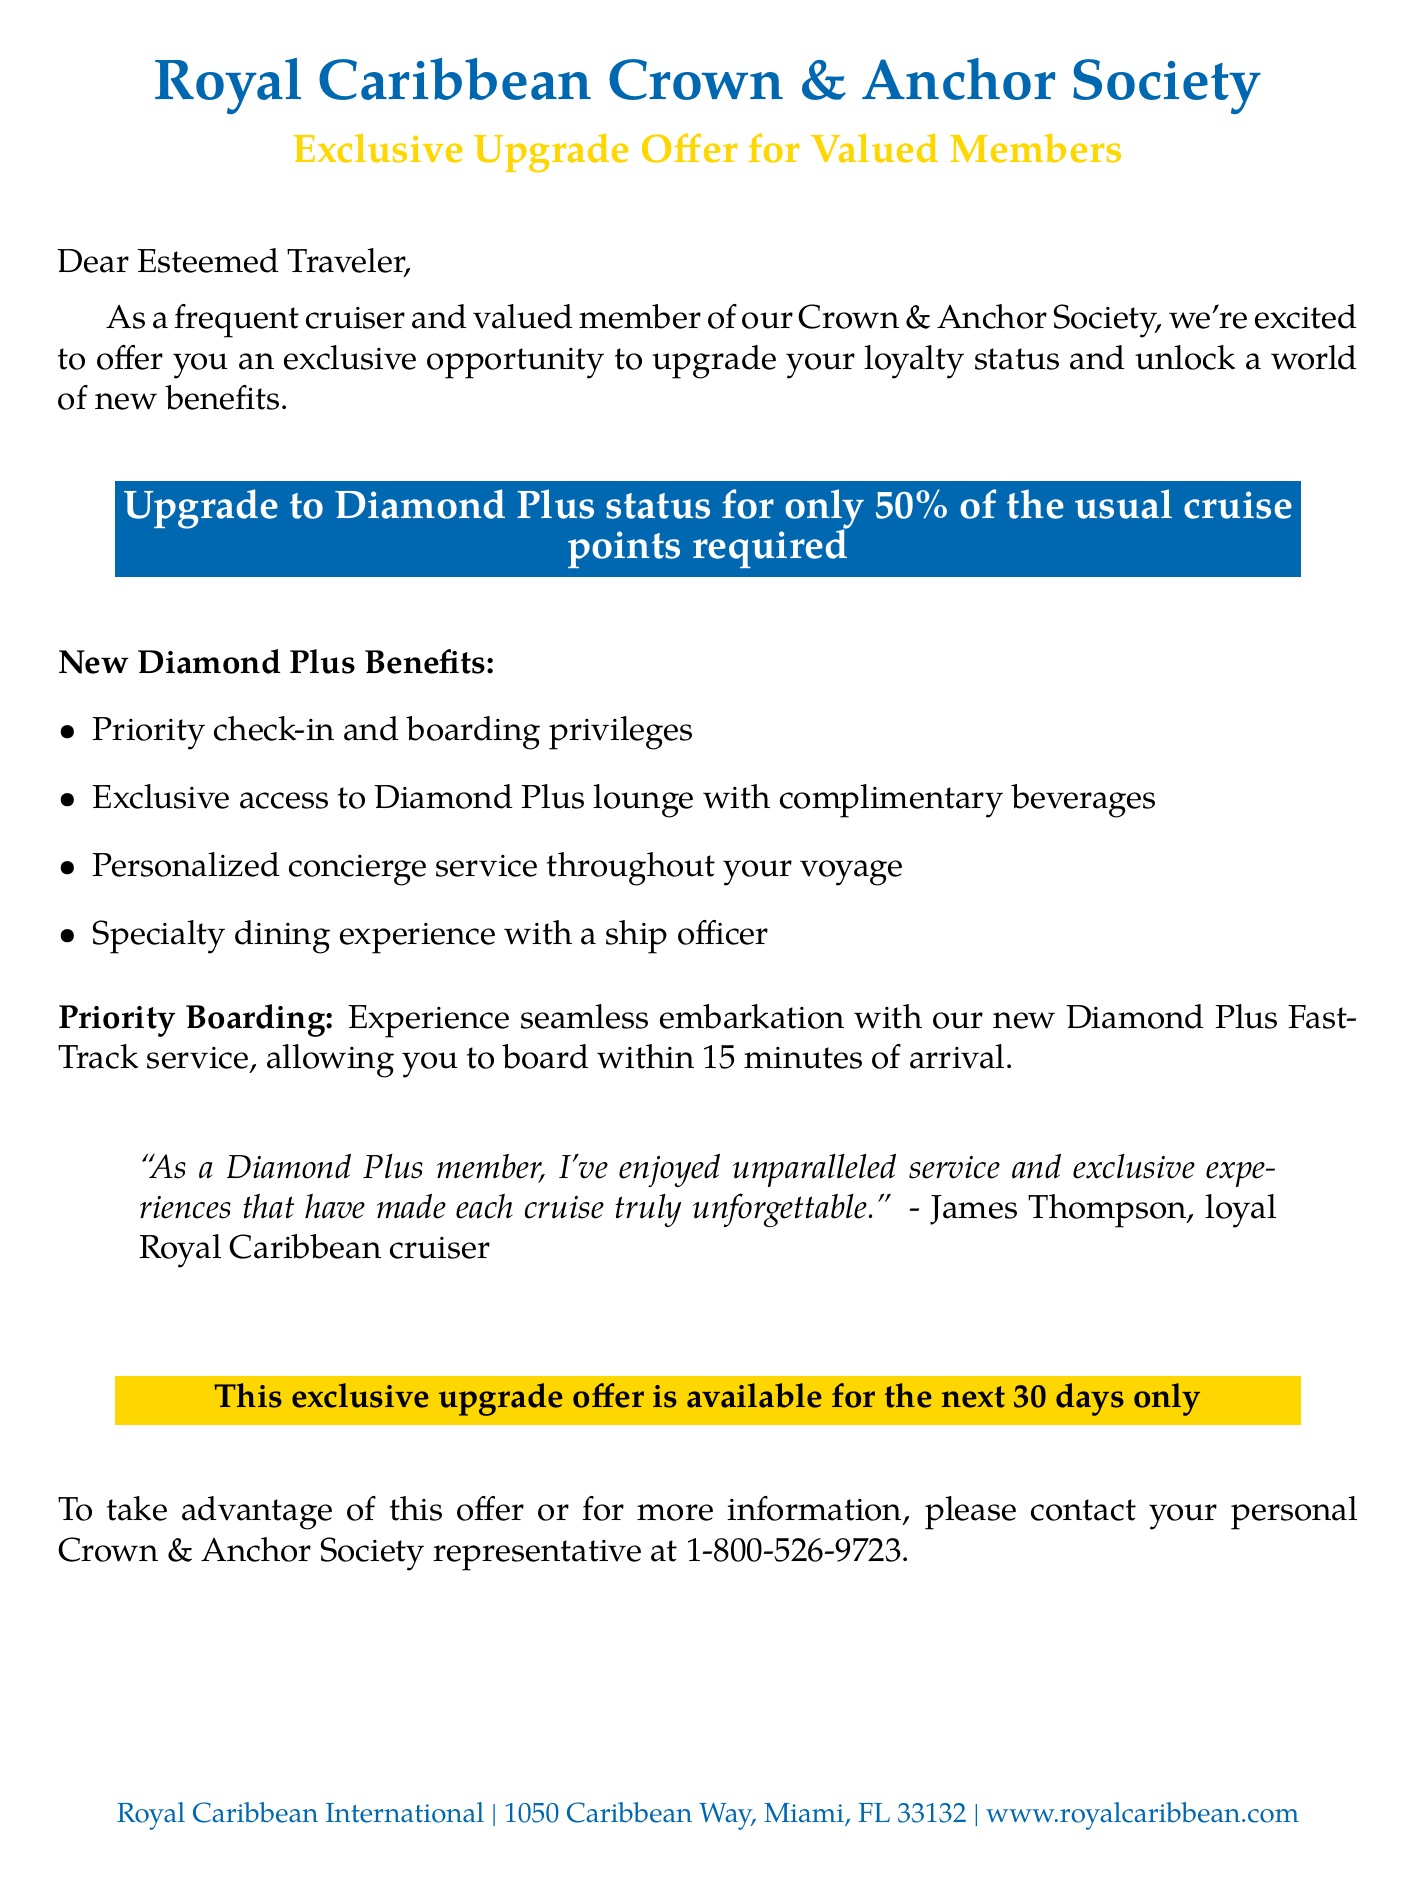What is the name of the loyalty program? The name of the loyalty program is mentioned as "Crown & Anchor Society."
Answer: Crown & Anchor Society What is the upgrade offer for? The upgrade offer is specifically for "Diamond Plus status."
Answer: Diamond Plus status How much of the usual cruise points is required for the upgrade? The document states that the upgrade requires "50% of the usual cruise points."
Answer: 50% What is one of the new benefits of Diamond Plus status? The new benefits listed include "Priority check-in and boarding privileges."
Answer: Priority check-in and boarding privileges What is the name of the FastTrack service? The FastTrack service mentioned in the document is called "Diamond Plus FastTrack."
Answer: Diamond Plus FastTrack How long is the exclusive upgrade offer available? The document states that the exclusive upgrade offer is available for "the next 30 days only."
Answer: the next 30 days only Who can be contacted for more information about the offer? The document specifies that members should contact their "personal Crown & Anchor Society representative."
Answer: personal Crown & Anchor Society representative Which city is Royal Caribbean International based in? The document provides the location as "Miami."
Answer: Miami 